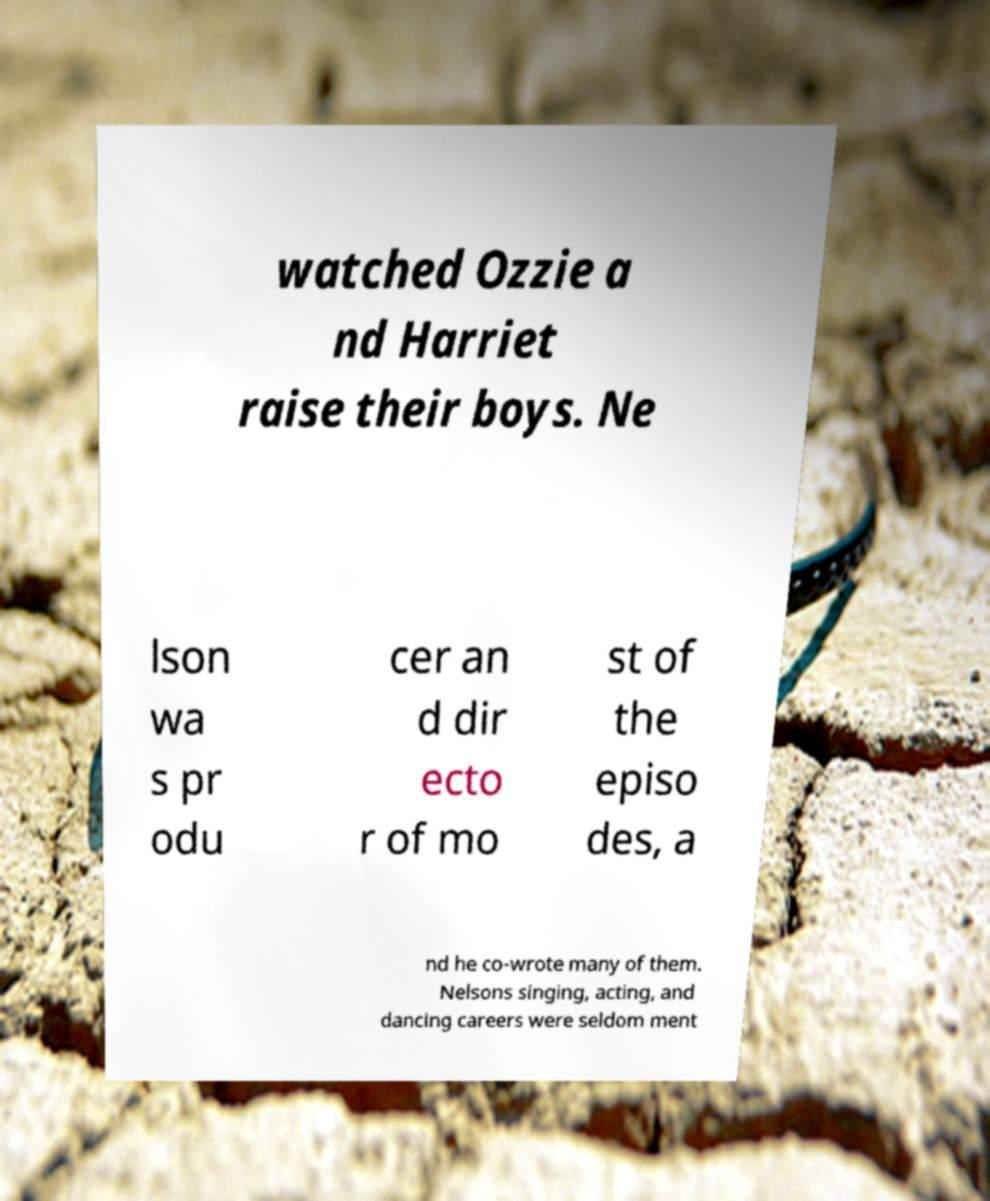Could you assist in decoding the text presented in this image and type it out clearly? watched Ozzie a nd Harriet raise their boys. Ne lson wa s pr odu cer an d dir ecto r of mo st of the episo des, a nd he co-wrote many of them. Nelsons singing, acting, and dancing careers were seldom ment 